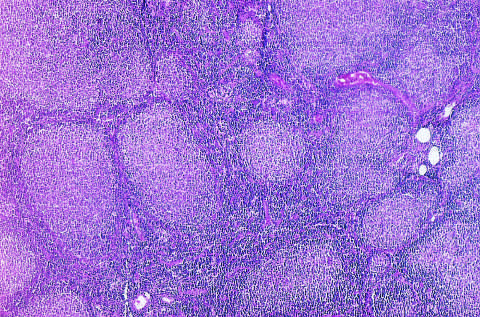re nodular aggregates of lymphoma cells present throughout?
Answer the question using a single word or phrase. Yes 